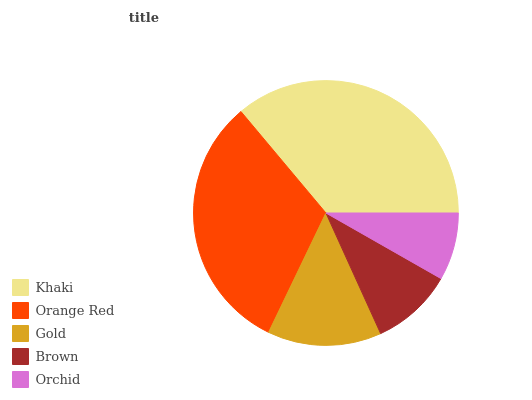Is Orchid the minimum?
Answer yes or no. Yes. Is Khaki the maximum?
Answer yes or no. Yes. Is Orange Red the minimum?
Answer yes or no. No. Is Orange Red the maximum?
Answer yes or no. No. Is Khaki greater than Orange Red?
Answer yes or no. Yes. Is Orange Red less than Khaki?
Answer yes or no. Yes. Is Orange Red greater than Khaki?
Answer yes or no. No. Is Khaki less than Orange Red?
Answer yes or no. No. Is Gold the high median?
Answer yes or no. Yes. Is Gold the low median?
Answer yes or no. Yes. Is Orchid the high median?
Answer yes or no. No. Is Orchid the low median?
Answer yes or no. No. 